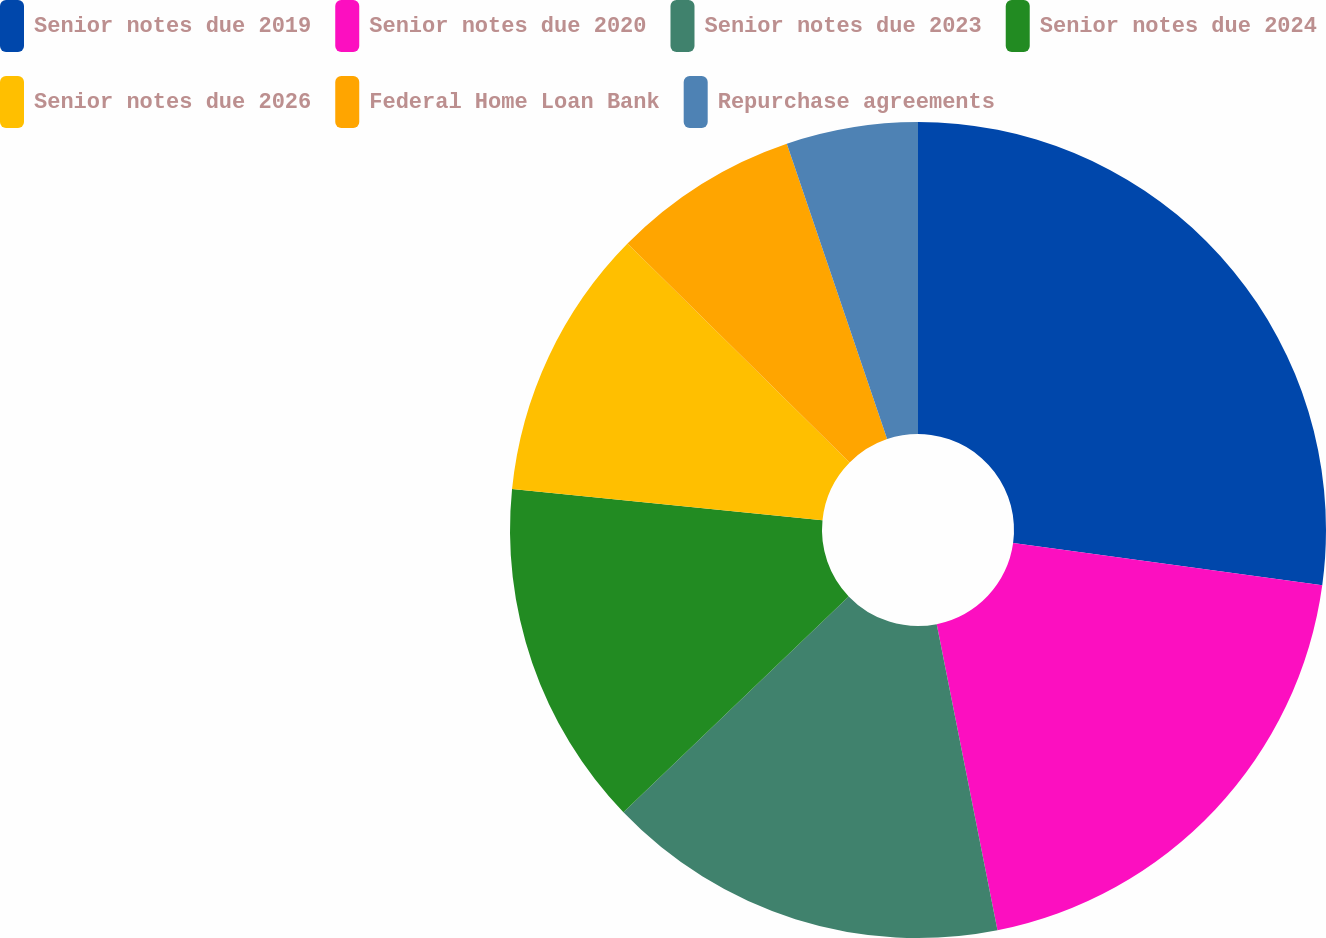Convert chart to OTSL. <chart><loc_0><loc_0><loc_500><loc_500><pie_chart><fcel>Senior notes due 2019<fcel>Senior notes due 2020<fcel>Senior notes due 2023<fcel>Senior notes due 2024<fcel>Senior notes due 2026<fcel>Federal Home Loan Bank<fcel>Repurchase agreements<nl><fcel>27.16%<fcel>19.72%<fcel>15.96%<fcel>13.76%<fcel>10.79%<fcel>7.4%<fcel>5.21%<nl></chart> 